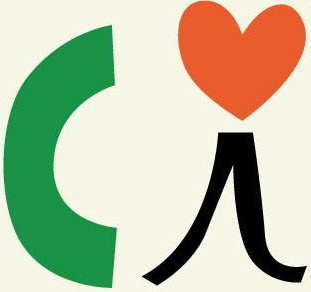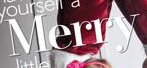What words can you see in these images in sequence, separated by a semicolon? Ci; Merry 